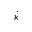<formula> <loc_0><loc_0><loc_500><loc_500>\dot { \kappa }</formula> 